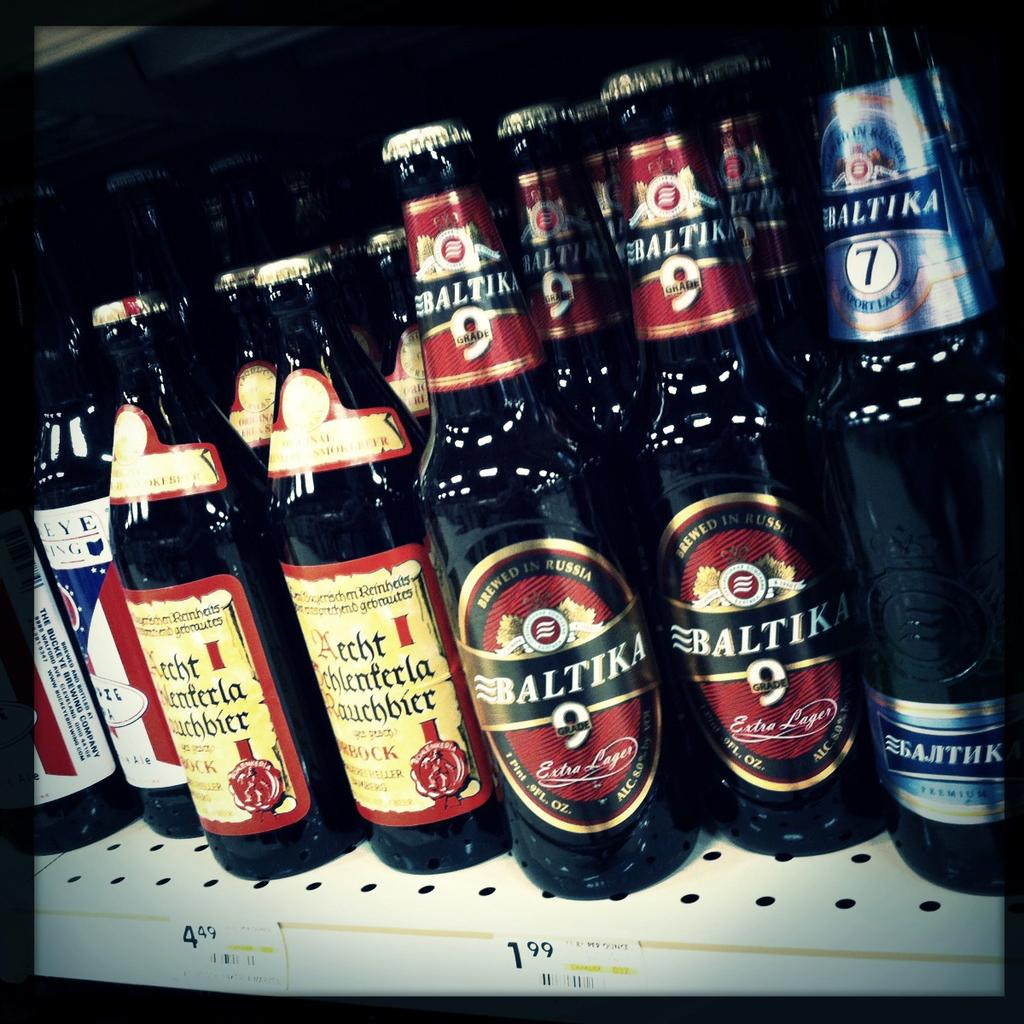<image>
Render a clear and concise summary of the photo. Bottles of Baltika 9 and Baltika 7 amongst other bottles. 